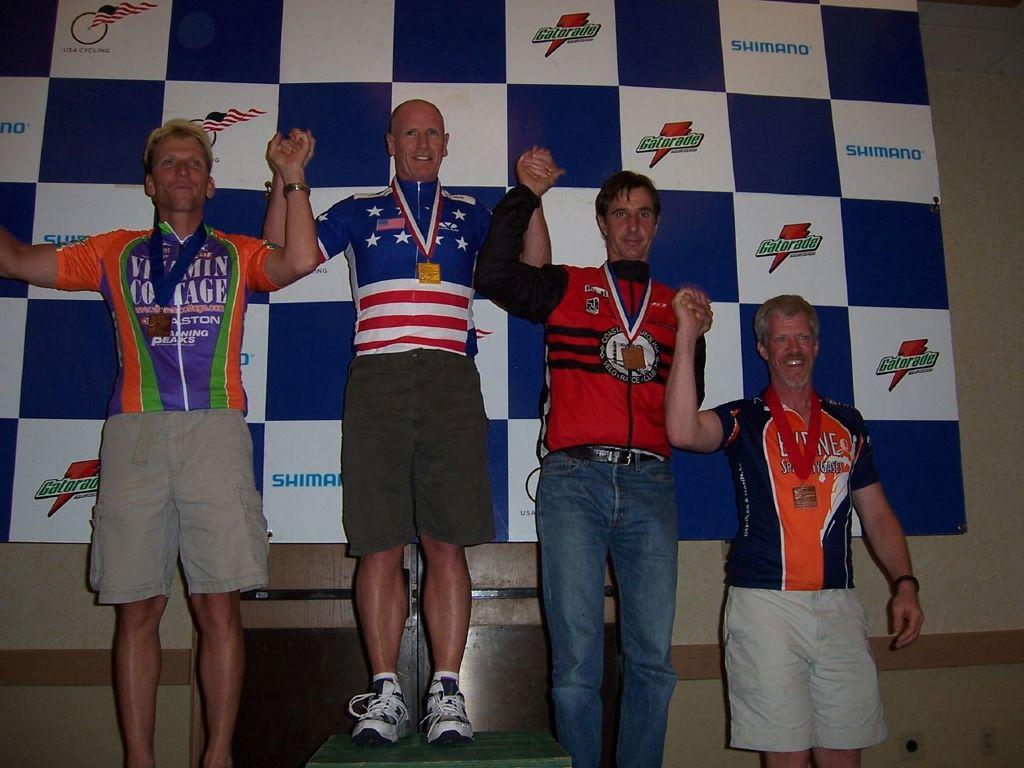<image>
Offer a succinct explanation of the picture presented. People posing in front of a poster on a wall that says GATORADE. 